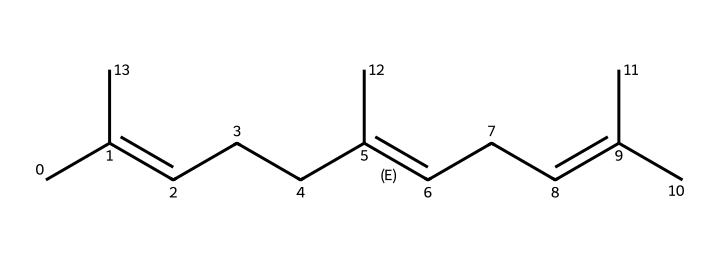What is the molecular formula of myrcene? To determine the molecular formula, count the number of carbon (C) and hydrogen (H) atoms based on the SMILES representation. In this case, there are 10 carbon atoms and 16 hydrogen atoms. Therefore, the molecular formula is C10H16.
Answer: C10H16 How many double bonds are present in myrcene? By analyzing the SMILES notation, we can identify double bonds through the "=" symbol. In the structure provided, there are 3 occurrences of "=" indicating 3 double bonds.
Answer: 3 What type of compound is myrcene classified as? Myrcene fits the definition of a terpene which is a type of compound chiefly made of hydrocarbons and derived from plant essential oils. The structure exhibits a characteristic feature of terpenes, which is multiple double bonds and branched structures.
Answer: terpene What is the degree of unsaturation in myrcene? The degree of unsaturation can be calculated by the formula (1 + number of rings + number of double bonds). Myrcene has 0 rings and 3 double bonds. Thus, the degree of unsaturation is 1 + 0 + 3 = 4.
Answer: 4 Which part of the structure indicates myrcene's floral aroma? The branched chain structure present in myrcene, particularly with the presence of multiple double bonds and the configuration of carbon atoms, contributes to its floral aroma. This specific configuration aligns with the characteristics typically found in aromatic compounds.
Answer: branched chain What is the main source of myrcene in plants? Myrcene is predominantly found in essential oils derived from various plants, especially those belonging to the cannabis and hop families. The composition results from natural biosynthetic processes in plants that produce terpenes for aroma and defense.
Answer: cannabis and hops How many rings are present in myrcene's structure? In the SMILES representation of myrcene, there are no ring structures involved, which would be represented by "C" connecting to itself in a loop. Therefore, the count of rings is zero.
Answer: 0 